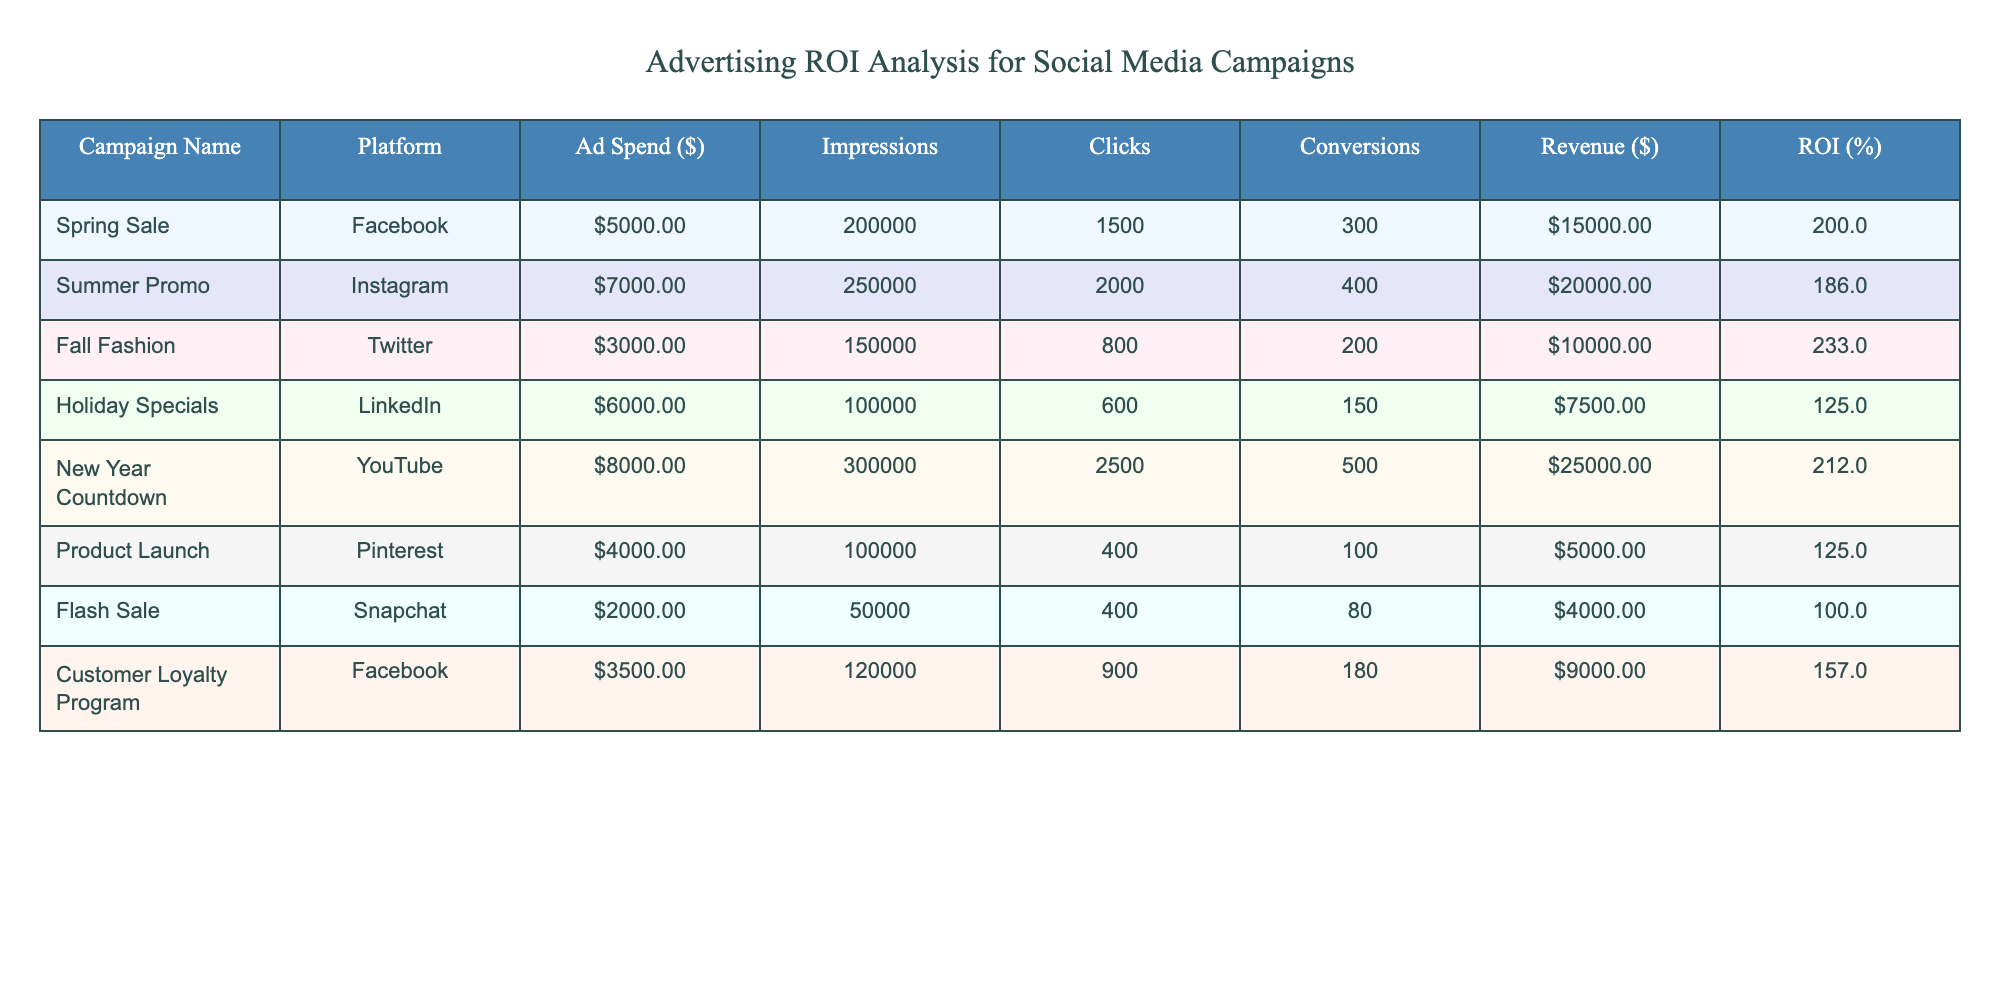What is the total revenue generated across all campaigns? To find the total revenue, we sum the Revenue column values: 15000 + 20000 + 10000 + 7500 + 25000 + 5000 + 4000 + 9000 = 80000.
Answer: 80000 Which campaign had the highest ROI? The Highest ROI can be found by comparing the ROI percentage in the table. The Fall Fashion campaign has an ROI of 233%, which is the highest among all campaigns.
Answer: Fall Fashion What is the average ad spend for the campaigns? We calculate the average by summing the Ad Spend values: 5000 + 7000 + 3000 + 6000 + 8000 + 4000 + 2000 + 3500 = 36000. Then divide by the number of campaigns (8): 36000 / 8 = 4500.
Answer: 4500 Did the Holiday Specials campaign have a higher revenue than the Flash Sale campaign? The revenue for Holiday Specials is 7500, and for Flash Sale, it is 4000. Since 7500 is greater than 4000, the statement is true.
Answer: Yes What is the total number of conversions from all campaigns on Instagram? The Instagram campaigns listed are Summer Promo. It has 400 conversions. Since there are no other Instagram campaigns, the total is simply 400.
Answer: 400 How does the revenue of the New Year Countdown compare against the average revenue across all campaigns? The average revenue is calculated to be 80000 / 8 = 10000. The New Year Countdown campaign generated 25000, which is significantly higher than the average 10000.
Answer: Higher Is the total number of clicks from Facebook campaigns greater than those from Twitter campaigns? Facebook campaigns (Spring Sale and Customer Loyalty Program) have 1500 + 900 = 2400 clicks; Twitter (Fall Fashion) has 800 clicks. Since 2400 > 800, the answer is yes.
Answer: Yes What is the difference in ROI between the best-performing campaign and the worst-performing campaign? The best-performing campaign (Fall Fashion) has an ROI of 233% and the worst (Holiday Specials) has 125%. The difference is 233 - 125 = 108.
Answer: 108 Which platform generated the most revenue? We assess revenue by platform: Facebook = 15000 + 9000 = 24000, Instagram = 20000, Twitter = 10000, LinkedIn = 7500, YouTube = 25000, Pinterest = 5000, Snapchat = 4000. The highest is from Instagram with 20000.
Answer: YouTube 